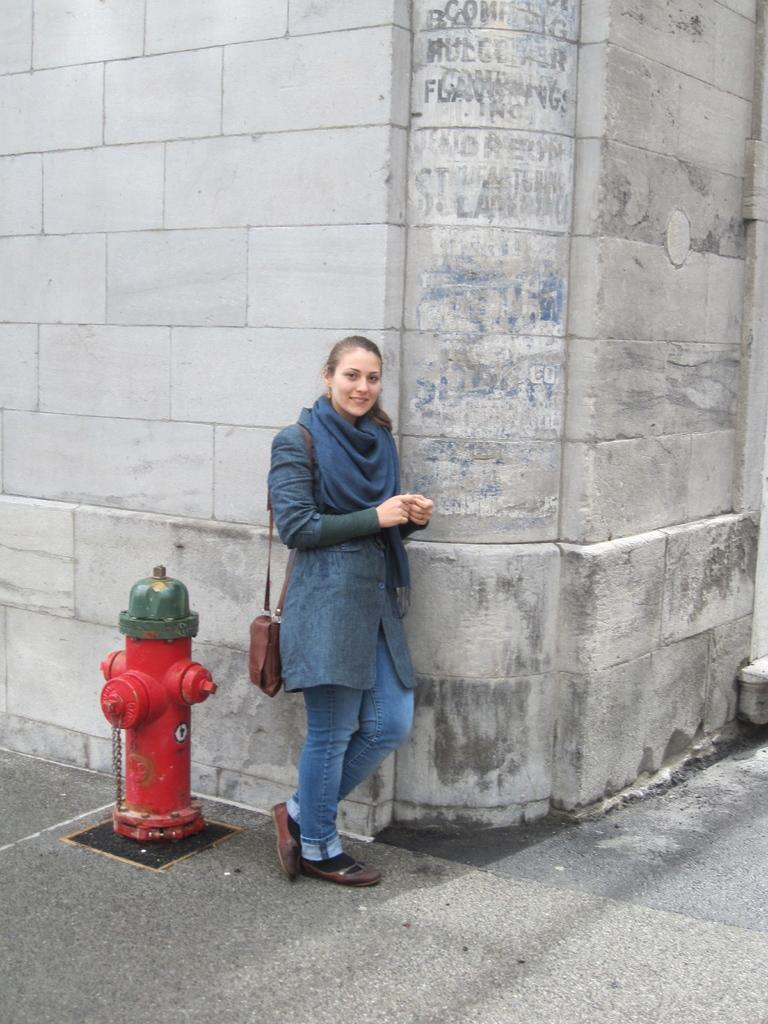What is the main subject of the image? There is a woman standing in the image. What object can be seen near the woman? There is a fire hydrant in the image. What is visible in the background of the image? There is a wall in the background of the image. How many pies are being shaded by the woman in the image? There are no pies present in the image, and the woman is not providing shade to any objects. 